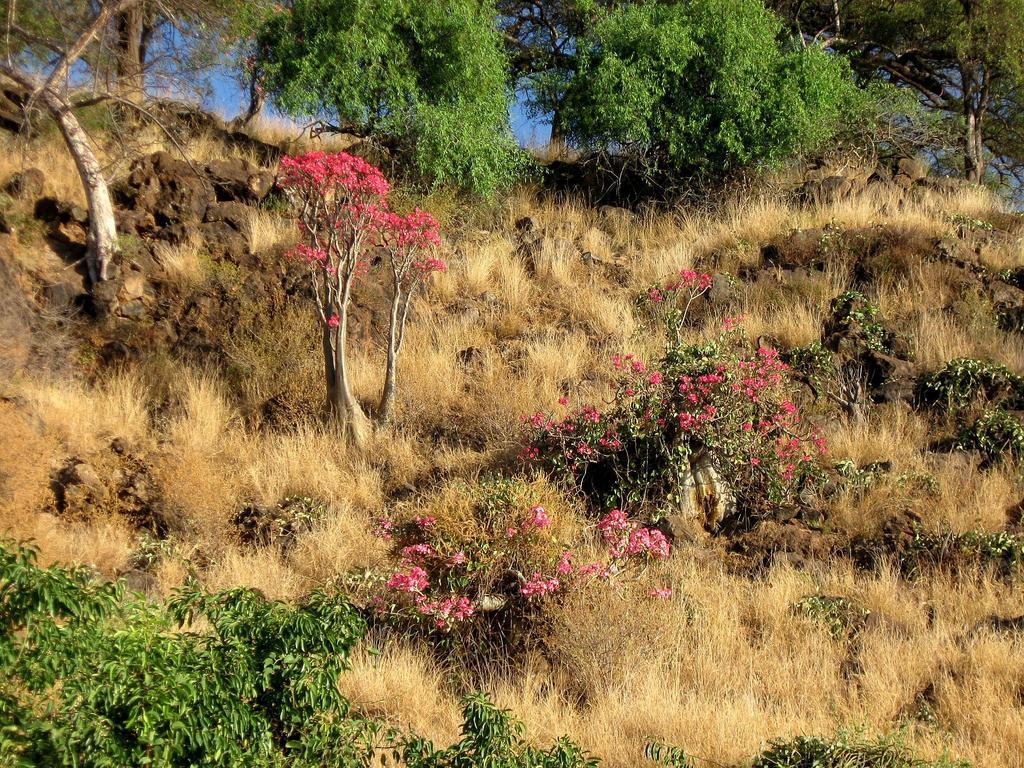What type of vegetation can be seen in the image? There is grass, plants, and trees in the image. What other natural elements are present in the image? There are rocks in the image. What can be seen in the background of the image? The sky is visible in the background of the image. What type of loaf is being used as a hat in the image? There is no loaf or hat present in the image; it features natural elements such as grass, plants, trees, rocks, and the sky. What color are the jeans worn by the cabbage in the image? There is no cabbage or jeans present in the image. 